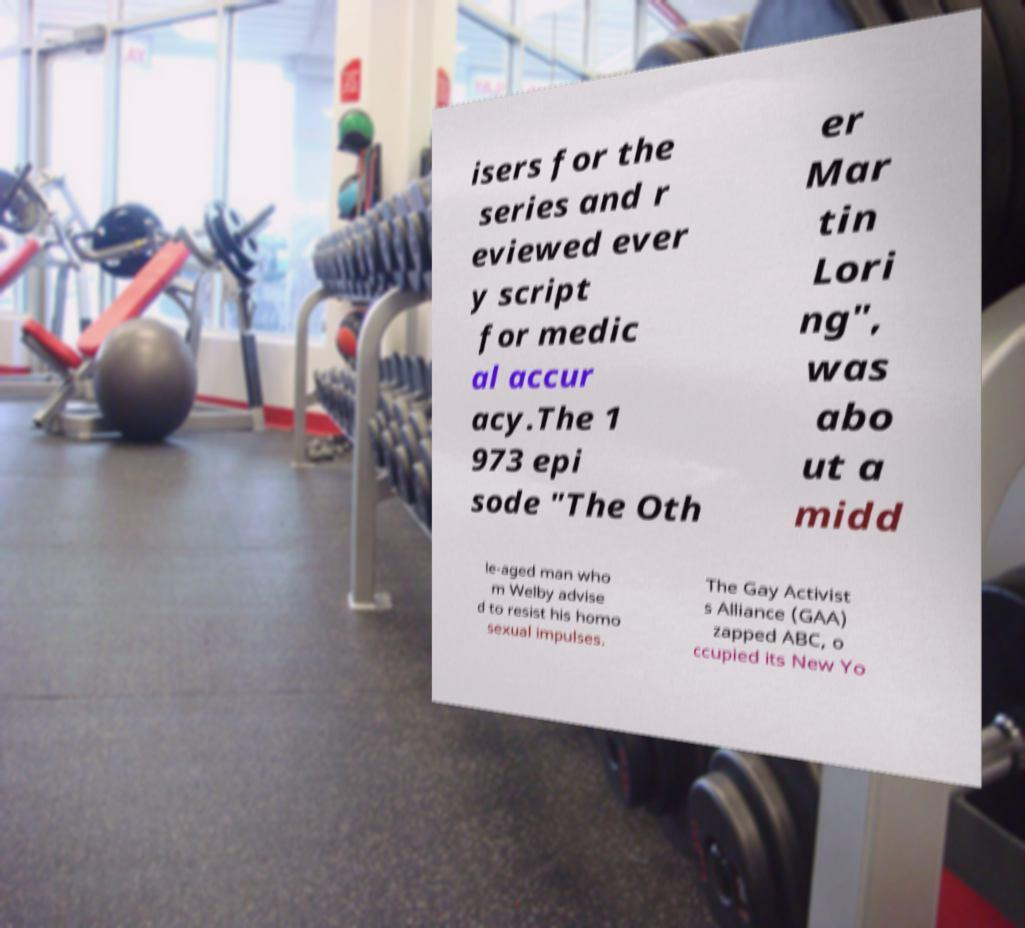I need the written content from this picture converted into text. Can you do that? isers for the series and r eviewed ever y script for medic al accur acy.The 1 973 epi sode "The Oth er Mar tin Lori ng", was abo ut a midd le-aged man who m Welby advise d to resist his homo sexual impulses. The Gay Activist s Alliance (GAA) zapped ABC, o ccupied its New Yo 